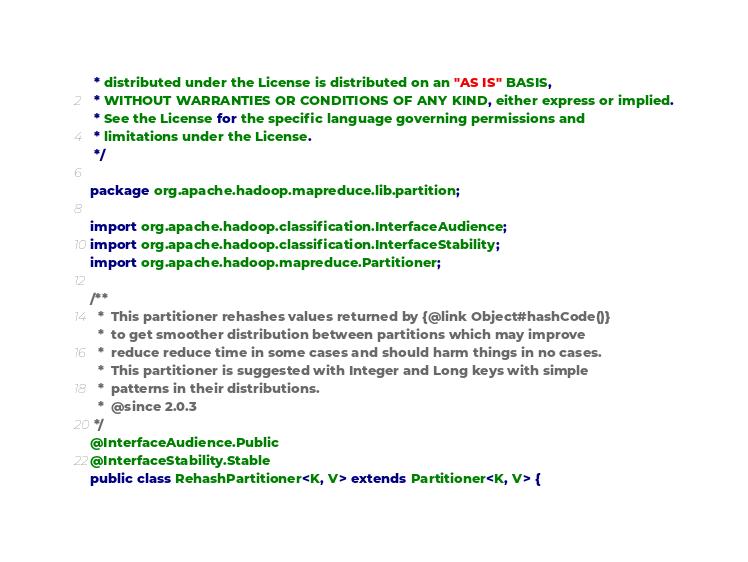<code> <loc_0><loc_0><loc_500><loc_500><_Java_> * distributed under the License is distributed on an "AS IS" BASIS,
 * WITHOUT WARRANTIES OR CONDITIONS OF ANY KIND, either express or implied.
 * See the License for the specific language governing permissions and
 * limitations under the License.
 */

package org.apache.hadoop.mapreduce.lib.partition;

import org.apache.hadoop.classification.InterfaceAudience;
import org.apache.hadoop.classification.InterfaceStability;
import org.apache.hadoop.mapreduce.Partitioner;

/**
  *  This partitioner rehashes values returned by {@link Object#hashCode()}
  *  to get smoother distribution between partitions which may improve
  *  reduce reduce time in some cases and should harm things in no cases.
  *  This partitioner is suggested with Integer and Long keys with simple
  *  patterns in their distributions.
  *  @since 2.0.3
 */
@InterfaceAudience.Public
@InterfaceStability.Stable
public class RehashPartitioner<K, V> extends Partitioner<K, V> {
</code> 